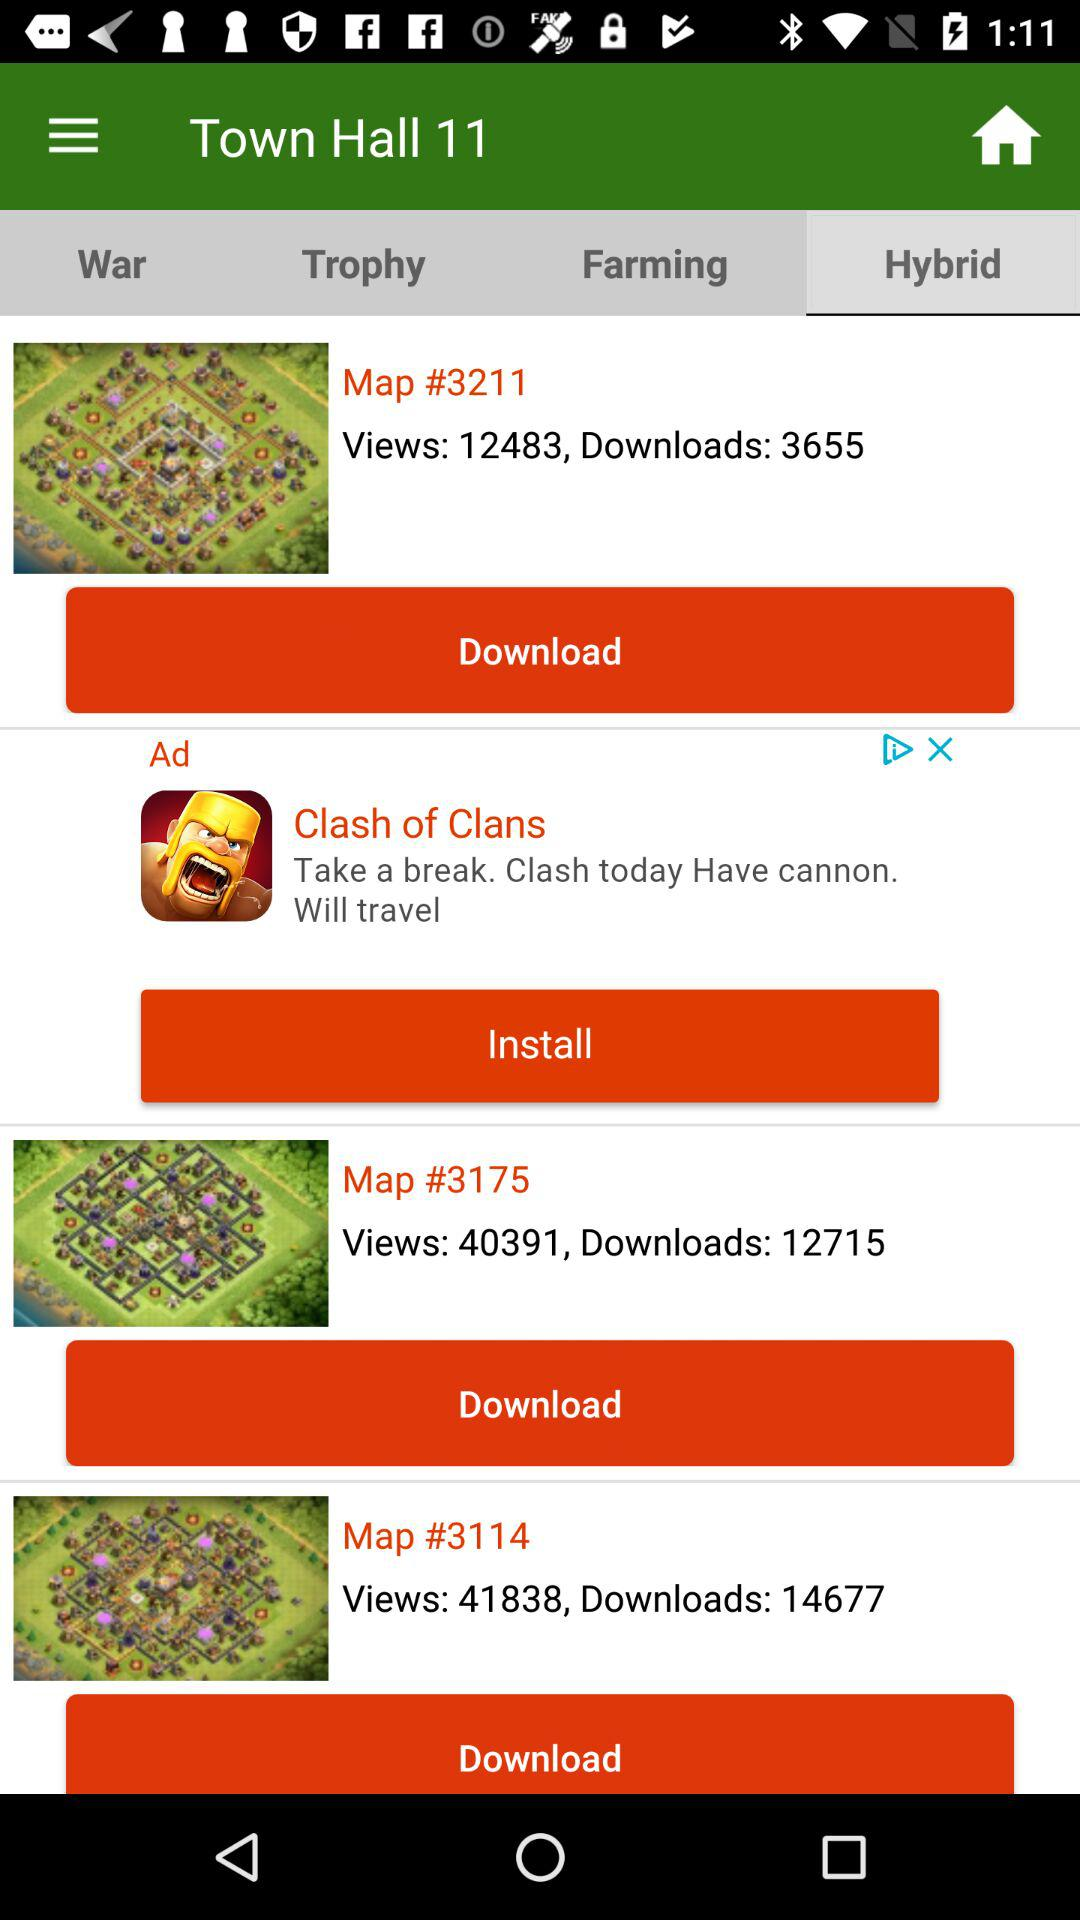Which tab am I using? You are using the "Hybrid" tab. 